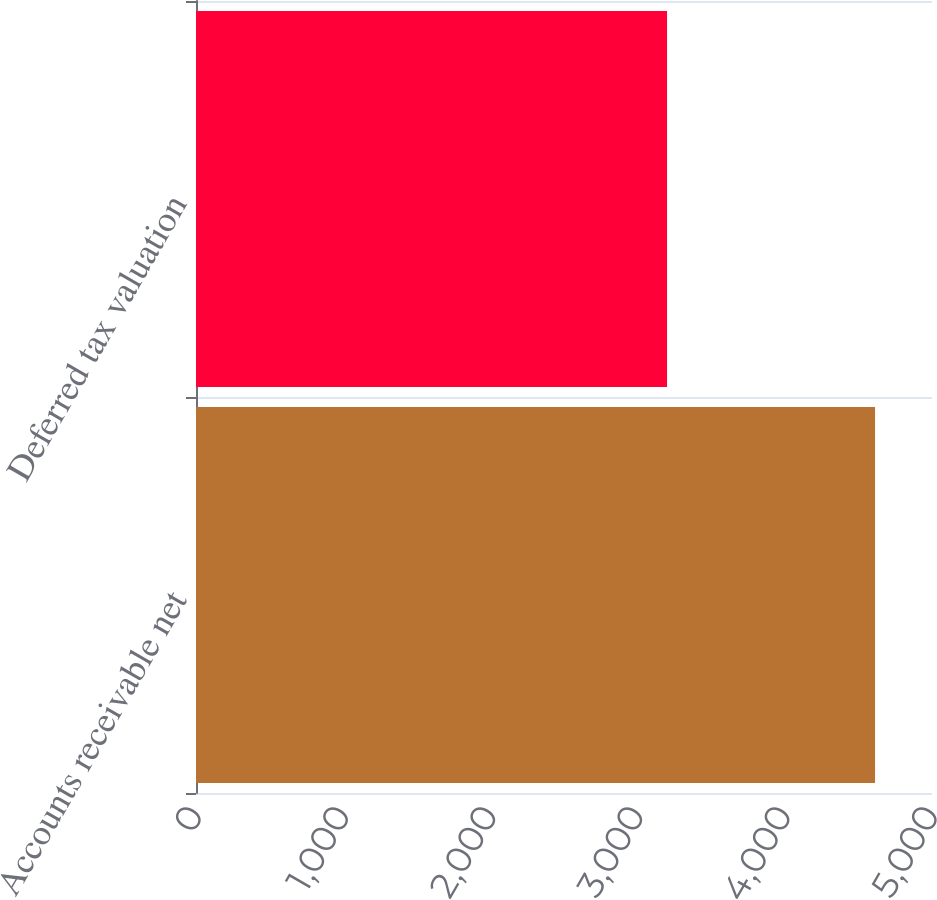<chart> <loc_0><loc_0><loc_500><loc_500><bar_chart><fcel>Accounts receivable net<fcel>Deferred tax valuation<nl><fcel>4613<fcel>3200<nl></chart> 